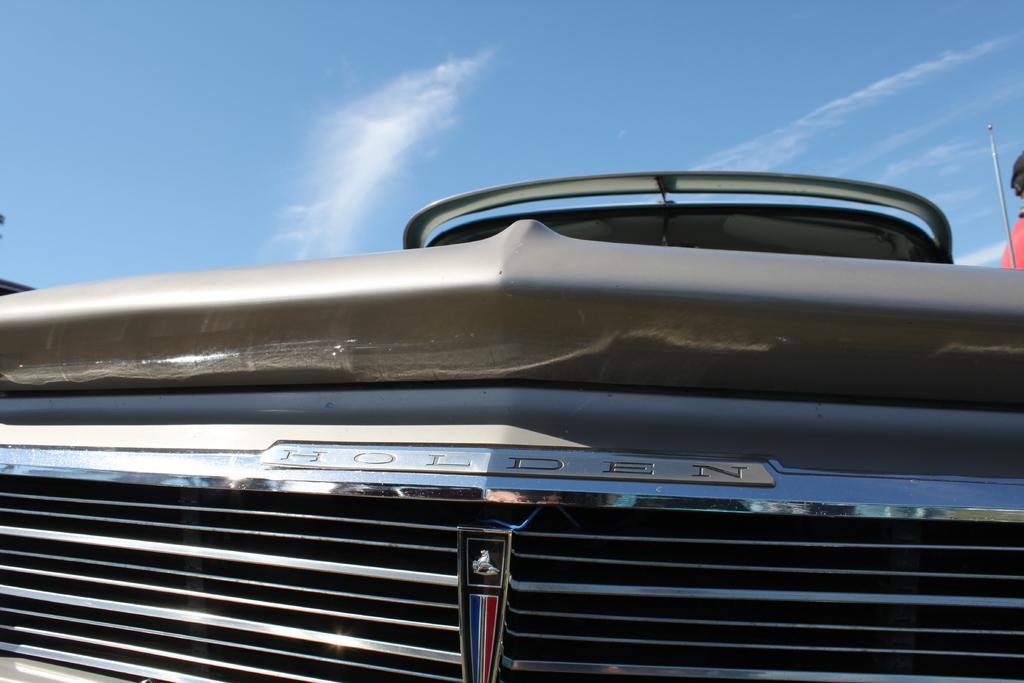What is the main subject of the image? There is a vehicle in the image. Can you describe the person beside the vehicle? There is a person beside the vehicle. What can be seen in the background of the image? There is sky visible in the background of the image. What is the condition of the sky in the image? Clouds are present in the sky. What type of grass is growing on the person's head in the image? There is no grass present in the image, let alone growing on the person's head. 